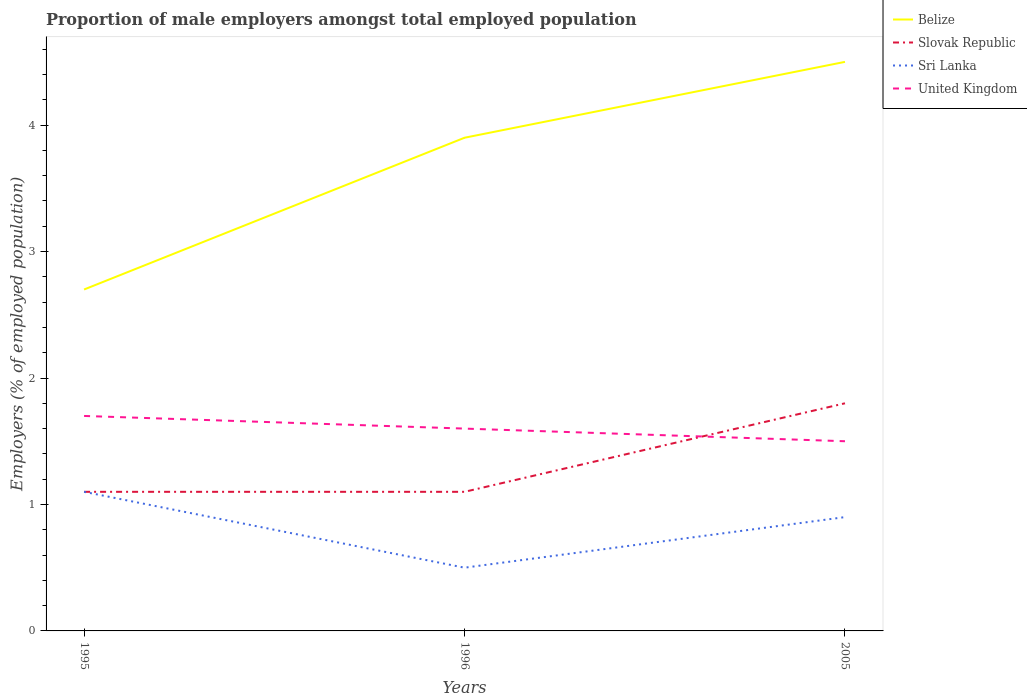Is the number of lines equal to the number of legend labels?
Provide a short and direct response. Yes. Across all years, what is the maximum proportion of male employers in Belize?
Keep it short and to the point. 2.7. What is the total proportion of male employers in Sri Lanka in the graph?
Offer a terse response. 0.6. What is the difference between the highest and the second highest proportion of male employers in Sri Lanka?
Your answer should be very brief. 0.6. Is the proportion of male employers in Sri Lanka strictly greater than the proportion of male employers in United Kingdom over the years?
Offer a terse response. Yes. How many years are there in the graph?
Offer a terse response. 3. Are the values on the major ticks of Y-axis written in scientific E-notation?
Make the answer very short. No. Does the graph contain any zero values?
Give a very brief answer. No. Does the graph contain grids?
Ensure brevity in your answer.  No. Where does the legend appear in the graph?
Your answer should be compact. Top right. How are the legend labels stacked?
Give a very brief answer. Vertical. What is the title of the graph?
Provide a short and direct response. Proportion of male employers amongst total employed population. Does "High income: OECD" appear as one of the legend labels in the graph?
Give a very brief answer. No. What is the label or title of the X-axis?
Give a very brief answer. Years. What is the label or title of the Y-axis?
Ensure brevity in your answer.  Employers (% of employed population). What is the Employers (% of employed population) of Belize in 1995?
Give a very brief answer. 2.7. What is the Employers (% of employed population) of Slovak Republic in 1995?
Offer a very short reply. 1.1. What is the Employers (% of employed population) in Sri Lanka in 1995?
Make the answer very short. 1.1. What is the Employers (% of employed population) of United Kingdom in 1995?
Offer a very short reply. 1.7. What is the Employers (% of employed population) in Belize in 1996?
Your answer should be compact. 3.9. What is the Employers (% of employed population) of Slovak Republic in 1996?
Your response must be concise. 1.1. What is the Employers (% of employed population) in United Kingdom in 1996?
Your answer should be very brief. 1.6. What is the Employers (% of employed population) in Belize in 2005?
Provide a succinct answer. 4.5. What is the Employers (% of employed population) of Slovak Republic in 2005?
Offer a very short reply. 1.8. What is the Employers (% of employed population) of Sri Lanka in 2005?
Your answer should be compact. 0.9. Across all years, what is the maximum Employers (% of employed population) of Belize?
Your response must be concise. 4.5. Across all years, what is the maximum Employers (% of employed population) in Slovak Republic?
Offer a terse response. 1.8. Across all years, what is the maximum Employers (% of employed population) in Sri Lanka?
Offer a terse response. 1.1. Across all years, what is the maximum Employers (% of employed population) in United Kingdom?
Your answer should be compact. 1.7. Across all years, what is the minimum Employers (% of employed population) in Belize?
Offer a very short reply. 2.7. Across all years, what is the minimum Employers (% of employed population) of Slovak Republic?
Provide a succinct answer. 1.1. What is the total Employers (% of employed population) in Slovak Republic in the graph?
Give a very brief answer. 4. What is the total Employers (% of employed population) of Sri Lanka in the graph?
Your answer should be very brief. 2.5. What is the difference between the Employers (% of employed population) in Slovak Republic in 1995 and that in 1996?
Make the answer very short. 0. What is the difference between the Employers (% of employed population) of United Kingdom in 1995 and that in 1996?
Keep it short and to the point. 0.1. What is the difference between the Employers (% of employed population) of Belize in 1995 and that in 2005?
Offer a terse response. -1.8. What is the difference between the Employers (% of employed population) in Slovak Republic in 1995 and that in 2005?
Make the answer very short. -0.7. What is the difference between the Employers (% of employed population) in Sri Lanka in 1995 and that in 2005?
Offer a very short reply. 0.2. What is the difference between the Employers (% of employed population) in Belize in 1996 and that in 2005?
Give a very brief answer. -0.6. What is the difference between the Employers (% of employed population) of Slovak Republic in 1996 and that in 2005?
Provide a short and direct response. -0.7. What is the difference between the Employers (% of employed population) of United Kingdom in 1996 and that in 2005?
Ensure brevity in your answer.  0.1. What is the difference between the Employers (% of employed population) of Belize in 1995 and the Employers (% of employed population) of Slovak Republic in 1996?
Your answer should be very brief. 1.6. What is the difference between the Employers (% of employed population) in Belize in 1995 and the Employers (% of employed population) in Sri Lanka in 1996?
Ensure brevity in your answer.  2.2. What is the difference between the Employers (% of employed population) in Slovak Republic in 1995 and the Employers (% of employed population) in United Kingdom in 1996?
Your answer should be very brief. -0.5. What is the difference between the Employers (% of employed population) in Sri Lanka in 1995 and the Employers (% of employed population) in United Kingdom in 1996?
Keep it short and to the point. -0.5. What is the difference between the Employers (% of employed population) in Belize in 1995 and the Employers (% of employed population) in Sri Lanka in 2005?
Offer a very short reply. 1.8. What is the difference between the Employers (% of employed population) of Slovak Republic in 1995 and the Employers (% of employed population) of Sri Lanka in 2005?
Your response must be concise. 0.2. What is the difference between the Employers (% of employed population) in Sri Lanka in 1995 and the Employers (% of employed population) in United Kingdom in 2005?
Offer a terse response. -0.4. What is the difference between the Employers (% of employed population) in Belize in 1996 and the Employers (% of employed population) in Slovak Republic in 2005?
Keep it short and to the point. 2.1. What is the difference between the Employers (% of employed population) of Belize in 1996 and the Employers (% of employed population) of Sri Lanka in 2005?
Ensure brevity in your answer.  3. What is the difference between the Employers (% of employed population) of Belize in 1996 and the Employers (% of employed population) of United Kingdom in 2005?
Provide a succinct answer. 2.4. What is the difference between the Employers (% of employed population) of Slovak Republic in 1996 and the Employers (% of employed population) of Sri Lanka in 2005?
Make the answer very short. 0.2. What is the difference between the Employers (% of employed population) in Slovak Republic in 1996 and the Employers (% of employed population) in United Kingdom in 2005?
Offer a terse response. -0.4. What is the average Employers (% of employed population) of Sri Lanka per year?
Ensure brevity in your answer.  0.83. What is the average Employers (% of employed population) of United Kingdom per year?
Offer a terse response. 1.6. In the year 1995, what is the difference between the Employers (% of employed population) in Belize and Employers (% of employed population) in Slovak Republic?
Offer a terse response. 1.6. In the year 1996, what is the difference between the Employers (% of employed population) of Belize and Employers (% of employed population) of Slovak Republic?
Make the answer very short. 2.8. In the year 1996, what is the difference between the Employers (% of employed population) in Belize and Employers (% of employed population) in Sri Lanka?
Provide a short and direct response. 3.4. In the year 1996, what is the difference between the Employers (% of employed population) of Belize and Employers (% of employed population) of United Kingdom?
Offer a terse response. 2.3. In the year 1996, what is the difference between the Employers (% of employed population) in Slovak Republic and Employers (% of employed population) in Sri Lanka?
Provide a short and direct response. 0.6. In the year 2005, what is the difference between the Employers (% of employed population) in Slovak Republic and Employers (% of employed population) in Sri Lanka?
Your answer should be compact. 0.9. In the year 2005, what is the difference between the Employers (% of employed population) in Sri Lanka and Employers (% of employed population) in United Kingdom?
Provide a short and direct response. -0.6. What is the ratio of the Employers (% of employed population) of Belize in 1995 to that in 1996?
Offer a terse response. 0.69. What is the ratio of the Employers (% of employed population) of Slovak Republic in 1995 to that in 1996?
Give a very brief answer. 1. What is the ratio of the Employers (% of employed population) of Sri Lanka in 1995 to that in 1996?
Offer a very short reply. 2.2. What is the ratio of the Employers (% of employed population) of United Kingdom in 1995 to that in 1996?
Keep it short and to the point. 1.06. What is the ratio of the Employers (% of employed population) of Slovak Republic in 1995 to that in 2005?
Keep it short and to the point. 0.61. What is the ratio of the Employers (% of employed population) in Sri Lanka in 1995 to that in 2005?
Your response must be concise. 1.22. What is the ratio of the Employers (% of employed population) in United Kingdom in 1995 to that in 2005?
Keep it short and to the point. 1.13. What is the ratio of the Employers (% of employed population) in Belize in 1996 to that in 2005?
Offer a terse response. 0.87. What is the ratio of the Employers (% of employed population) of Slovak Republic in 1996 to that in 2005?
Provide a succinct answer. 0.61. What is the ratio of the Employers (% of employed population) of Sri Lanka in 1996 to that in 2005?
Make the answer very short. 0.56. What is the ratio of the Employers (% of employed population) of United Kingdom in 1996 to that in 2005?
Offer a terse response. 1.07. What is the difference between the highest and the lowest Employers (% of employed population) in Slovak Republic?
Give a very brief answer. 0.7. 